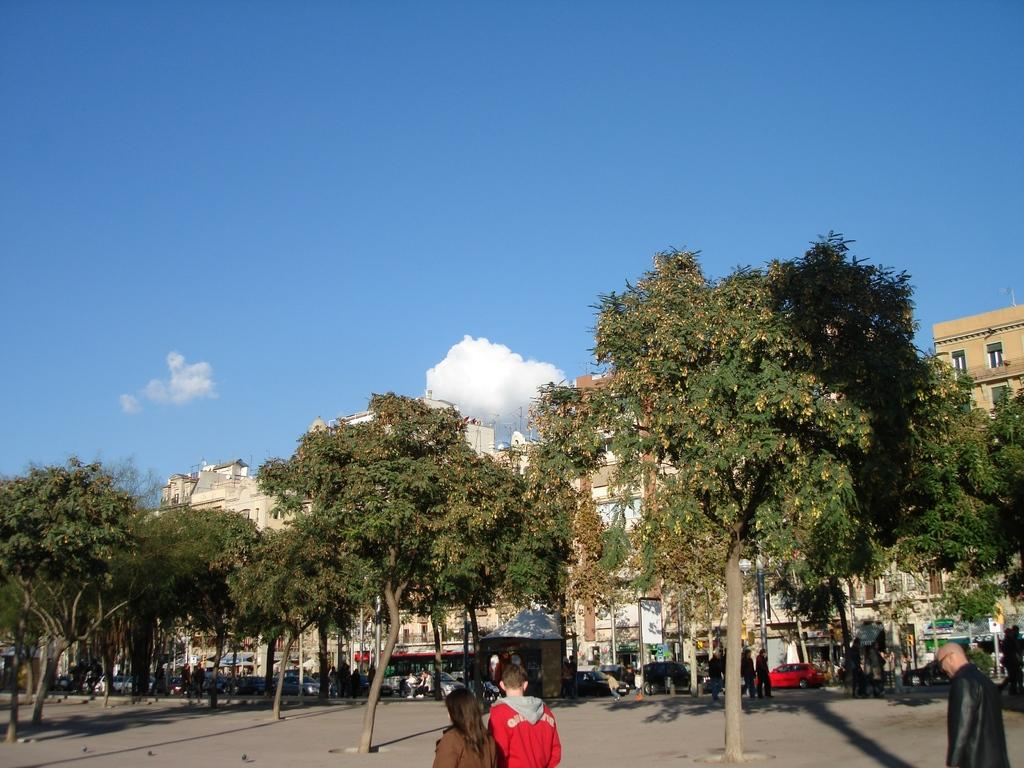What is happening on the road in the image? There are people on the road in the image. What type of natural elements can be seen in the image? There are trees visible in the image. What can be seen in the distance in the image? There are vehicles and buildings in the background of the image. What is visible in the sky in the background of the image? There are clouds in the sky in the background of the image. What type of card is being used for writing in the image? There is no card or writing present in the image. What type of humor can be seen in the image? There is no humor depicted in the image; it shows people on the road, trees, vehicles, buildings, and clouds. 